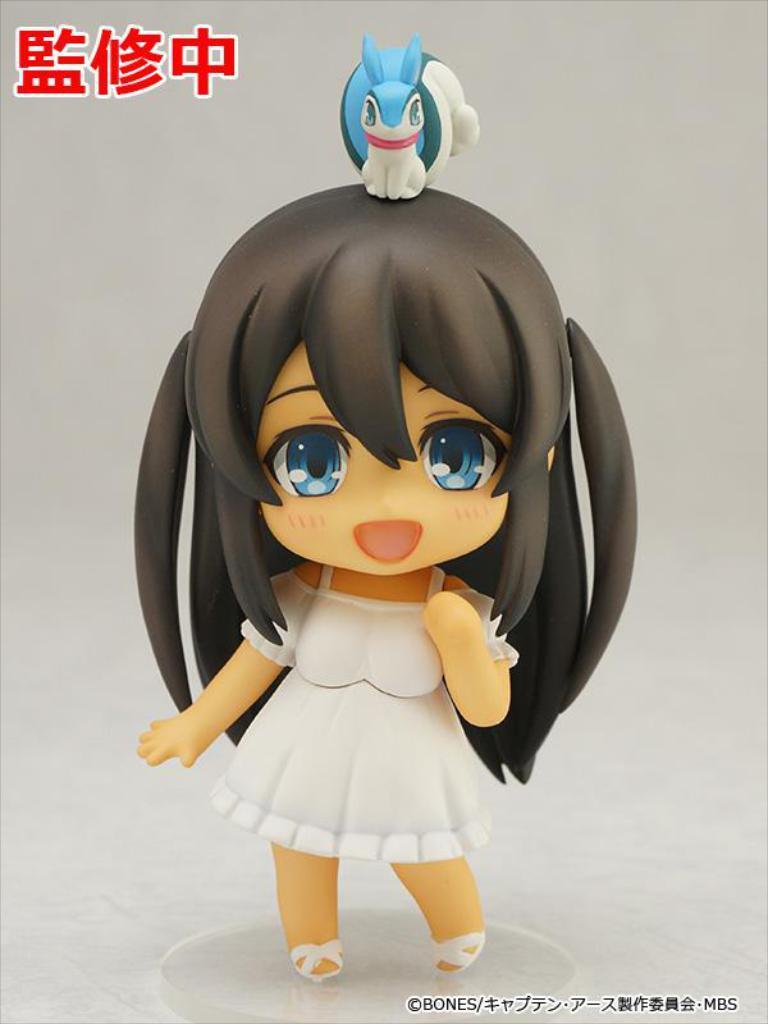Could you give a brief overview of what you see in this image? In this image there is a toy of a person on a surface, there is a toy of an animal, there is text towards the bottom of the image, there is text towards the top of the image, the background of the image is white in color. 